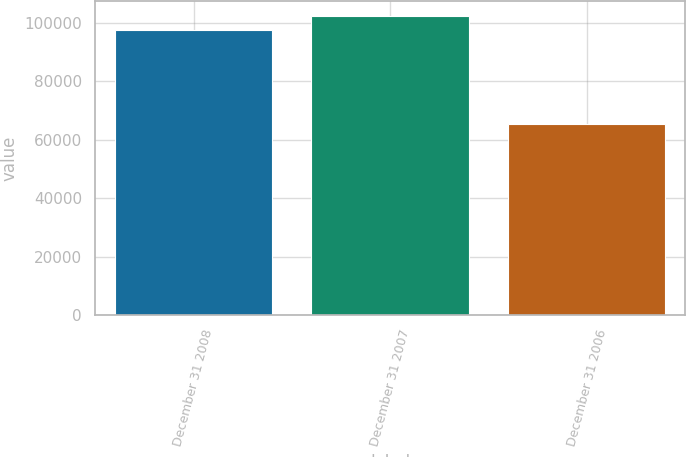Convert chart to OTSL. <chart><loc_0><loc_0><loc_500><loc_500><bar_chart><fcel>December 31 2008<fcel>December 31 2007<fcel>December 31 2006<nl><fcel>97441<fcel>102243<fcel>65428<nl></chart> 